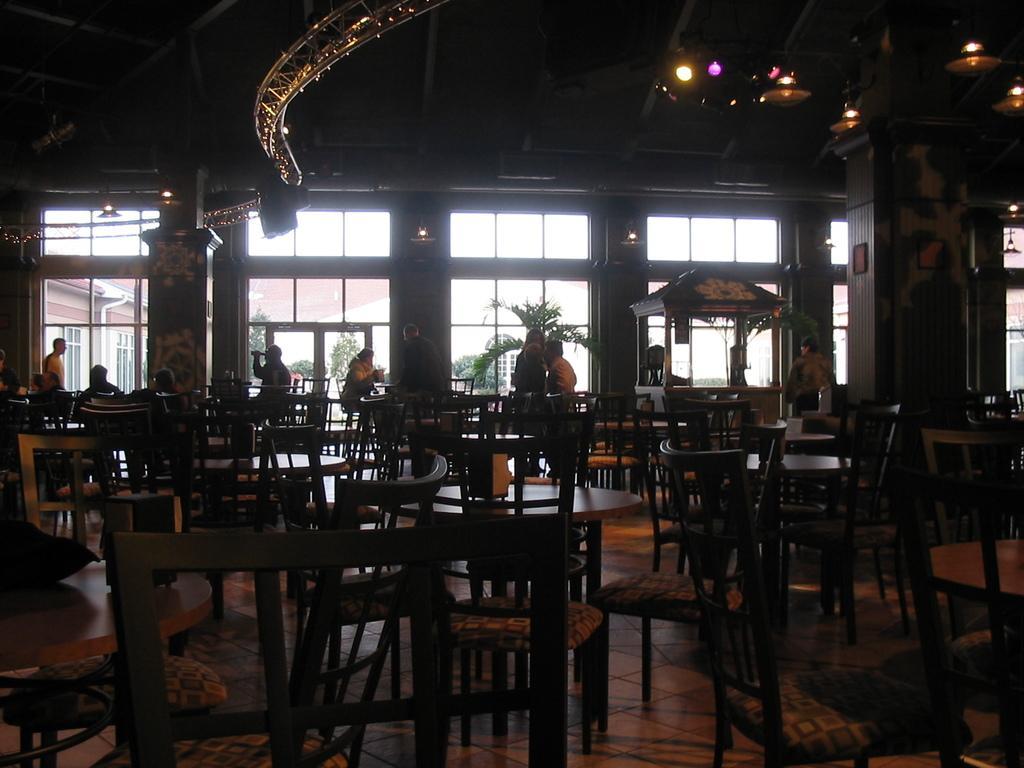Could you give a brief overview of what you see in this image? In this images we can see chairs at the tables on the floor. In the background there are few persons, plants, glass doors, lights on the ceiling, decorative items. Through the glass doors we can see trees and buildings and sky. 